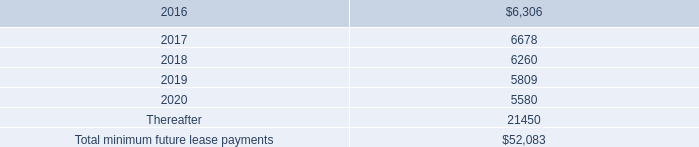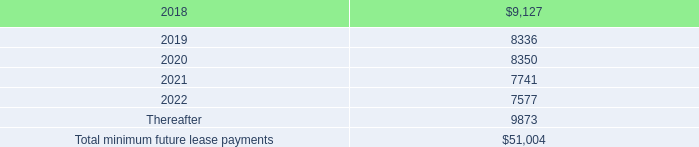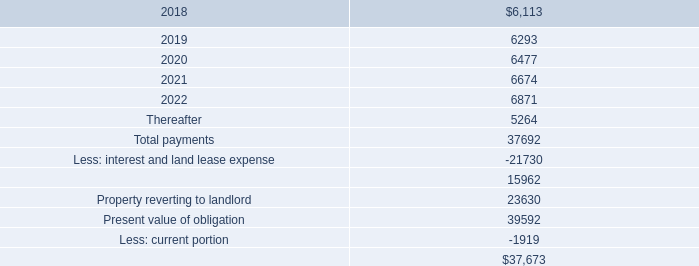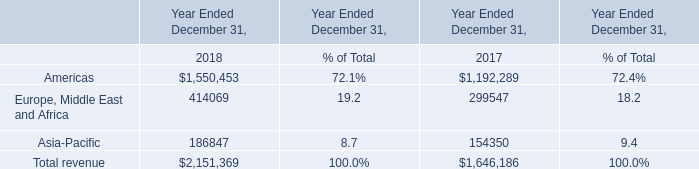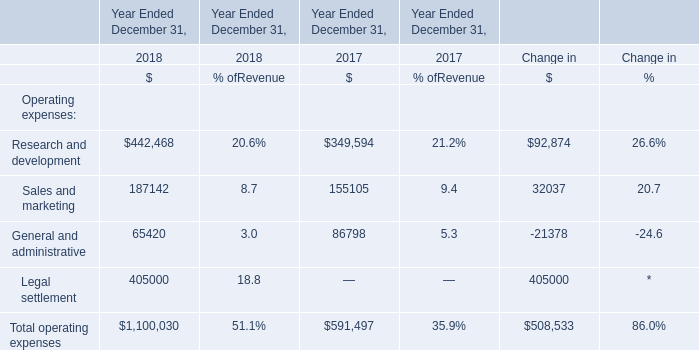How many subterms of Operating expenses keeps increasing between 2018 and 2017? 
Answer: 3. 